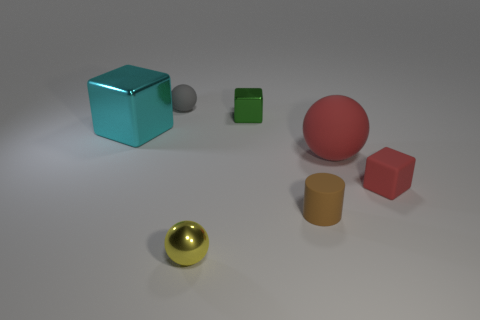Subtract all metal blocks. How many blocks are left? 1 Add 2 green spheres. How many objects exist? 9 Subtract all spheres. How many objects are left? 4 Subtract 0 brown balls. How many objects are left? 7 Subtract all green shiny spheres. Subtract all tiny yellow shiny objects. How many objects are left? 6 Add 5 big metallic objects. How many big metallic objects are left? 6 Add 5 yellow cubes. How many yellow cubes exist? 5 